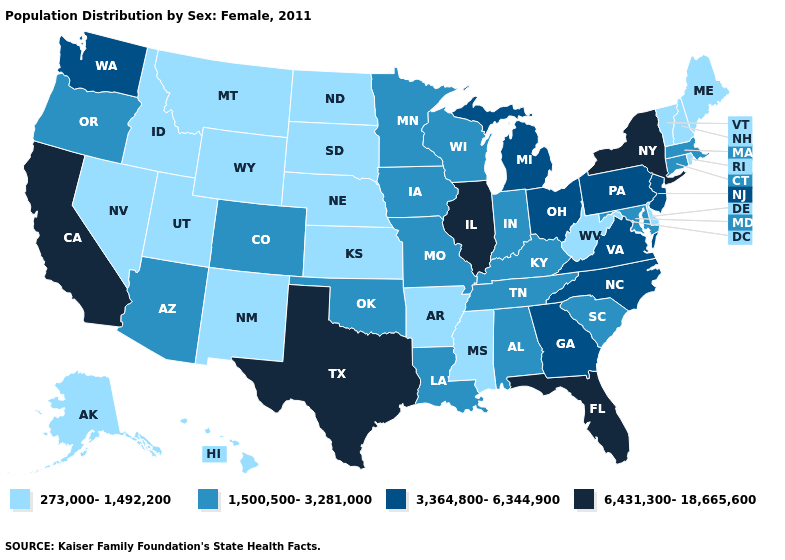Name the states that have a value in the range 1,500,500-3,281,000?
Concise answer only. Alabama, Arizona, Colorado, Connecticut, Indiana, Iowa, Kentucky, Louisiana, Maryland, Massachusetts, Minnesota, Missouri, Oklahoma, Oregon, South Carolina, Tennessee, Wisconsin. Which states have the lowest value in the West?
Quick response, please. Alaska, Hawaii, Idaho, Montana, Nevada, New Mexico, Utah, Wyoming. What is the value of Ohio?
Be succinct. 3,364,800-6,344,900. Among the states that border Wyoming , which have the highest value?
Be succinct. Colorado. Which states hav the highest value in the MidWest?
Answer briefly. Illinois. What is the value of New Jersey?
Answer briefly. 3,364,800-6,344,900. What is the lowest value in states that border Louisiana?
Concise answer only. 273,000-1,492,200. Name the states that have a value in the range 3,364,800-6,344,900?
Quick response, please. Georgia, Michigan, New Jersey, North Carolina, Ohio, Pennsylvania, Virginia, Washington. What is the value of Massachusetts?
Give a very brief answer. 1,500,500-3,281,000. Does Connecticut have the highest value in the Northeast?
Answer briefly. No. Does the first symbol in the legend represent the smallest category?
Answer briefly. Yes. Is the legend a continuous bar?
Write a very short answer. No. Name the states that have a value in the range 3,364,800-6,344,900?
Write a very short answer. Georgia, Michigan, New Jersey, North Carolina, Ohio, Pennsylvania, Virginia, Washington. Name the states that have a value in the range 3,364,800-6,344,900?
Concise answer only. Georgia, Michigan, New Jersey, North Carolina, Ohio, Pennsylvania, Virginia, Washington. Which states hav the highest value in the Northeast?
Answer briefly. New York. 